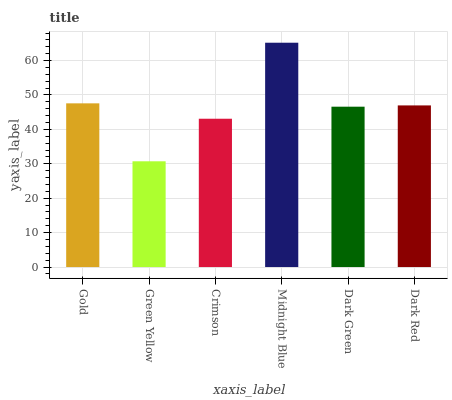Is Green Yellow the minimum?
Answer yes or no. Yes. Is Midnight Blue the maximum?
Answer yes or no. Yes. Is Crimson the minimum?
Answer yes or no. No. Is Crimson the maximum?
Answer yes or no. No. Is Crimson greater than Green Yellow?
Answer yes or no. Yes. Is Green Yellow less than Crimson?
Answer yes or no. Yes. Is Green Yellow greater than Crimson?
Answer yes or no. No. Is Crimson less than Green Yellow?
Answer yes or no. No. Is Dark Red the high median?
Answer yes or no. Yes. Is Dark Green the low median?
Answer yes or no. Yes. Is Midnight Blue the high median?
Answer yes or no. No. Is Green Yellow the low median?
Answer yes or no. No. 